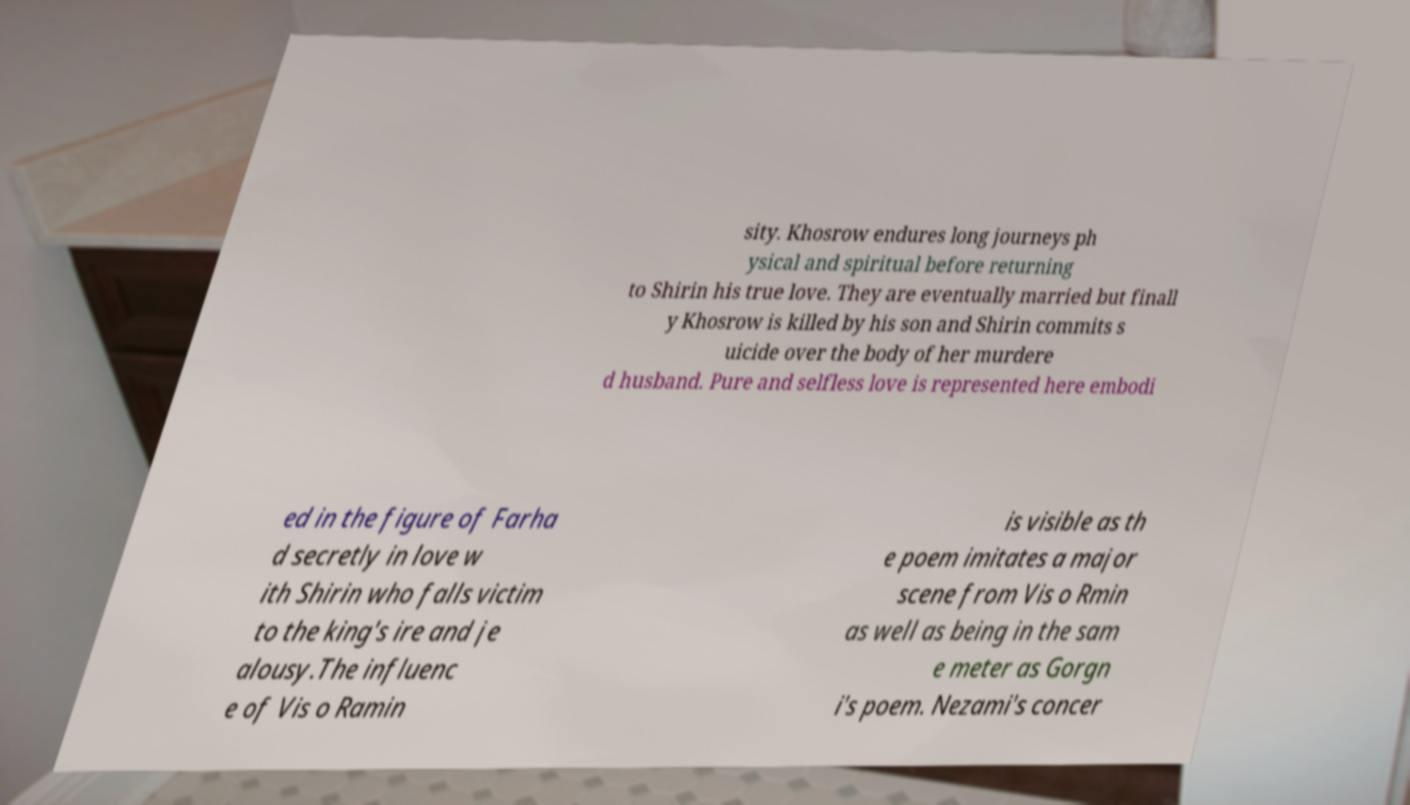I need the written content from this picture converted into text. Can you do that? sity. Khosrow endures long journeys ph ysical and spiritual before returning to Shirin his true love. They are eventually married but finall y Khosrow is killed by his son and Shirin commits s uicide over the body of her murdere d husband. Pure and selfless love is represented here embodi ed in the figure of Farha d secretly in love w ith Shirin who falls victim to the king's ire and je alousy.The influenc e of Vis o Ramin is visible as th e poem imitates a major scene from Vis o Rmin as well as being in the sam e meter as Gorgn i's poem. Nezami's concer 